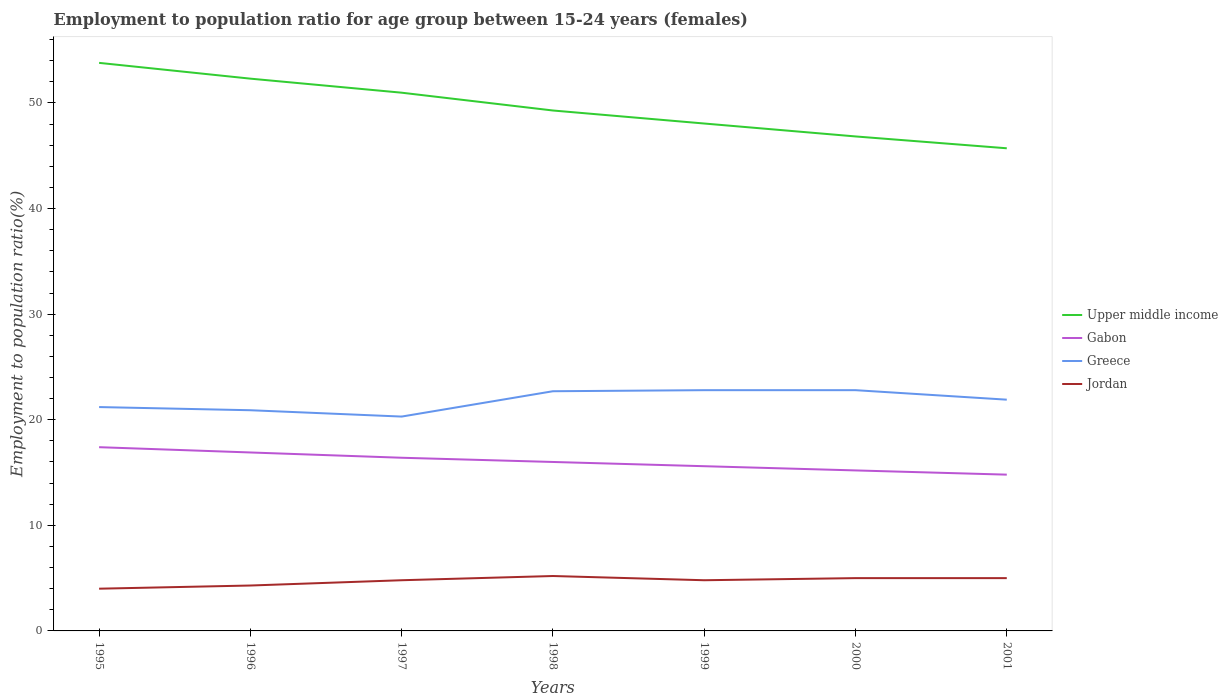How many different coloured lines are there?
Offer a very short reply. 4. Across all years, what is the maximum employment to population ratio in Gabon?
Provide a succinct answer. 14.8. In which year was the employment to population ratio in Jordan maximum?
Offer a terse response. 1995. What is the total employment to population ratio in Greece in the graph?
Offer a terse response. 0.9. What is the difference between the highest and the second highest employment to population ratio in Jordan?
Keep it short and to the point. 1.2. What is the difference between the highest and the lowest employment to population ratio in Jordan?
Keep it short and to the point. 5. How many lines are there?
Make the answer very short. 4. How many years are there in the graph?
Provide a succinct answer. 7. Does the graph contain any zero values?
Your response must be concise. No. Where does the legend appear in the graph?
Ensure brevity in your answer.  Center right. What is the title of the graph?
Provide a succinct answer. Employment to population ratio for age group between 15-24 years (females). What is the Employment to population ratio(%) of Upper middle income in 1995?
Keep it short and to the point. 53.8. What is the Employment to population ratio(%) in Gabon in 1995?
Your answer should be compact. 17.4. What is the Employment to population ratio(%) in Greece in 1995?
Your response must be concise. 21.2. What is the Employment to population ratio(%) of Upper middle income in 1996?
Offer a very short reply. 52.3. What is the Employment to population ratio(%) of Gabon in 1996?
Your answer should be very brief. 16.9. What is the Employment to population ratio(%) of Greece in 1996?
Your answer should be very brief. 20.9. What is the Employment to population ratio(%) in Jordan in 1996?
Your answer should be compact. 4.3. What is the Employment to population ratio(%) of Upper middle income in 1997?
Provide a short and direct response. 50.97. What is the Employment to population ratio(%) in Gabon in 1997?
Provide a short and direct response. 16.4. What is the Employment to population ratio(%) of Greece in 1997?
Provide a succinct answer. 20.3. What is the Employment to population ratio(%) in Jordan in 1997?
Keep it short and to the point. 4.8. What is the Employment to population ratio(%) in Upper middle income in 1998?
Provide a short and direct response. 49.29. What is the Employment to population ratio(%) of Gabon in 1998?
Your answer should be compact. 16. What is the Employment to population ratio(%) of Greece in 1998?
Provide a succinct answer. 22.7. What is the Employment to population ratio(%) of Jordan in 1998?
Offer a terse response. 5.2. What is the Employment to population ratio(%) of Upper middle income in 1999?
Give a very brief answer. 48.05. What is the Employment to population ratio(%) in Gabon in 1999?
Ensure brevity in your answer.  15.6. What is the Employment to population ratio(%) in Greece in 1999?
Give a very brief answer. 22.8. What is the Employment to population ratio(%) of Jordan in 1999?
Offer a terse response. 4.8. What is the Employment to population ratio(%) of Upper middle income in 2000?
Give a very brief answer. 46.83. What is the Employment to population ratio(%) of Gabon in 2000?
Make the answer very short. 15.2. What is the Employment to population ratio(%) in Greece in 2000?
Offer a terse response. 22.8. What is the Employment to population ratio(%) of Upper middle income in 2001?
Make the answer very short. 45.71. What is the Employment to population ratio(%) of Gabon in 2001?
Offer a very short reply. 14.8. What is the Employment to population ratio(%) of Greece in 2001?
Offer a very short reply. 21.9. What is the Employment to population ratio(%) of Jordan in 2001?
Give a very brief answer. 5. Across all years, what is the maximum Employment to population ratio(%) in Upper middle income?
Make the answer very short. 53.8. Across all years, what is the maximum Employment to population ratio(%) of Gabon?
Your response must be concise. 17.4. Across all years, what is the maximum Employment to population ratio(%) of Greece?
Keep it short and to the point. 22.8. Across all years, what is the maximum Employment to population ratio(%) in Jordan?
Your response must be concise. 5.2. Across all years, what is the minimum Employment to population ratio(%) in Upper middle income?
Ensure brevity in your answer.  45.71. Across all years, what is the minimum Employment to population ratio(%) of Gabon?
Offer a terse response. 14.8. Across all years, what is the minimum Employment to population ratio(%) of Greece?
Provide a short and direct response. 20.3. Across all years, what is the minimum Employment to population ratio(%) of Jordan?
Provide a short and direct response. 4. What is the total Employment to population ratio(%) of Upper middle income in the graph?
Offer a terse response. 346.95. What is the total Employment to population ratio(%) in Gabon in the graph?
Your answer should be very brief. 112.3. What is the total Employment to population ratio(%) in Greece in the graph?
Your answer should be compact. 152.6. What is the total Employment to population ratio(%) in Jordan in the graph?
Provide a succinct answer. 33.1. What is the difference between the Employment to population ratio(%) of Upper middle income in 1995 and that in 1996?
Your answer should be very brief. 1.49. What is the difference between the Employment to population ratio(%) in Jordan in 1995 and that in 1996?
Offer a very short reply. -0.3. What is the difference between the Employment to population ratio(%) in Upper middle income in 1995 and that in 1997?
Your answer should be very brief. 2.82. What is the difference between the Employment to population ratio(%) of Gabon in 1995 and that in 1997?
Your answer should be compact. 1. What is the difference between the Employment to population ratio(%) of Greece in 1995 and that in 1997?
Give a very brief answer. 0.9. What is the difference between the Employment to population ratio(%) of Jordan in 1995 and that in 1997?
Provide a succinct answer. -0.8. What is the difference between the Employment to population ratio(%) of Upper middle income in 1995 and that in 1998?
Your response must be concise. 4.51. What is the difference between the Employment to population ratio(%) of Greece in 1995 and that in 1998?
Offer a terse response. -1.5. What is the difference between the Employment to population ratio(%) in Jordan in 1995 and that in 1998?
Your answer should be compact. -1.2. What is the difference between the Employment to population ratio(%) of Upper middle income in 1995 and that in 1999?
Keep it short and to the point. 5.74. What is the difference between the Employment to population ratio(%) of Jordan in 1995 and that in 1999?
Your response must be concise. -0.8. What is the difference between the Employment to population ratio(%) in Upper middle income in 1995 and that in 2000?
Offer a terse response. 6.97. What is the difference between the Employment to population ratio(%) of Gabon in 1995 and that in 2000?
Your response must be concise. 2.2. What is the difference between the Employment to population ratio(%) of Greece in 1995 and that in 2000?
Offer a very short reply. -1.6. What is the difference between the Employment to population ratio(%) in Jordan in 1995 and that in 2000?
Ensure brevity in your answer.  -1. What is the difference between the Employment to population ratio(%) in Upper middle income in 1995 and that in 2001?
Your answer should be very brief. 8.09. What is the difference between the Employment to population ratio(%) in Gabon in 1995 and that in 2001?
Your response must be concise. 2.6. What is the difference between the Employment to population ratio(%) in Greece in 1995 and that in 2001?
Give a very brief answer. -0.7. What is the difference between the Employment to population ratio(%) in Upper middle income in 1996 and that in 1997?
Ensure brevity in your answer.  1.33. What is the difference between the Employment to population ratio(%) of Gabon in 1996 and that in 1997?
Offer a very short reply. 0.5. What is the difference between the Employment to population ratio(%) in Greece in 1996 and that in 1997?
Offer a very short reply. 0.6. What is the difference between the Employment to population ratio(%) of Upper middle income in 1996 and that in 1998?
Your answer should be compact. 3.02. What is the difference between the Employment to population ratio(%) in Upper middle income in 1996 and that in 1999?
Make the answer very short. 4.25. What is the difference between the Employment to population ratio(%) of Greece in 1996 and that in 1999?
Your answer should be compact. -1.9. What is the difference between the Employment to population ratio(%) in Upper middle income in 1996 and that in 2000?
Keep it short and to the point. 5.47. What is the difference between the Employment to population ratio(%) in Gabon in 1996 and that in 2000?
Give a very brief answer. 1.7. What is the difference between the Employment to population ratio(%) in Upper middle income in 1996 and that in 2001?
Keep it short and to the point. 6.59. What is the difference between the Employment to population ratio(%) of Gabon in 1996 and that in 2001?
Offer a very short reply. 2.1. What is the difference between the Employment to population ratio(%) in Jordan in 1996 and that in 2001?
Offer a terse response. -0.7. What is the difference between the Employment to population ratio(%) in Upper middle income in 1997 and that in 1998?
Make the answer very short. 1.69. What is the difference between the Employment to population ratio(%) of Greece in 1997 and that in 1998?
Your answer should be compact. -2.4. What is the difference between the Employment to population ratio(%) in Jordan in 1997 and that in 1998?
Keep it short and to the point. -0.4. What is the difference between the Employment to population ratio(%) in Upper middle income in 1997 and that in 1999?
Offer a very short reply. 2.92. What is the difference between the Employment to population ratio(%) in Jordan in 1997 and that in 1999?
Provide a succinct answer. 0. What is the difference between the Employment to population ratio(%) in Upper middle income in 1997 and that in 2000?
Your response must be concise. 4.14. What is the difference between the Employment to population ratio(%) in Gabon in 1997 and that in 2000?
Offer a terse response. 1.2. What is the difference between the Employment to population ratio(%) of Greece in 1997 and that in 2000?
Keep it short and to the point. -2.5. What is the difference between the Employment to population ratio(%) of Upper middle income in 1997 and that in 2001?
Your response must be concise. 5.26. What is the difference between the Employment to population ratio(%) in Gabon in 1997 and that in 2001?
Your response must be concise. 1.6. What is the difference between the Employment to population ratio(%) of Greece in 1997 and that in 2001?
Offer a very short reply. -1.6. What is the difference between the Employment to population ratio(%) in Upper middle income in 1998 and that in 1999?
Provide a succinct answer. 1.23. What is the difference between the Employment to population ratio(%) of Greece in 1998 and that in 1999?
Your answer should be compact. -0.1. What is the difference between the Employment to population ratio(%) of Upper middle income in 1998 and that in 2000?
Give a very brief answer. 2.46. What is the difference between the Employment to population ratio(%) in Greece in 1998 and that in 2000?
Provide a succinct answer. -0.1. What is the difference between the Employment to population ratio(%) in Upper middle income in 1998 and that in 2001?
Give a very brief answer. 3.58. What is the difference between the Employment to population ratio(%) in Upper middle income in 1999 and that in 2000?
Give a very brief answer. 1.22. What is the difference between the Employment to population ratio(%) of Gabon in 1999 and that in 2000?
Ensure brevity in your answer.  0.4. What is the difference between the Employment to population ratio(%) in Greece in 1999 and that in 2000?
Offer a very short reply. 0. What is the difference between the Employment to population ratio(%) of Jordan in 1999 and that in 2000?
Offer a very short reply. -0.2. What is the difference between the Employment to population ratio(%) of Upper middle income in 1999 and that in 2001?
Ensure brevity in your answer.  2.35. What is the difference between the Employment to population ratio(%) in Upper middle income in 2000 and that in 2001?
Make the answer very short. 1.12. What is the difference between the Employment to population ratio(%) of Greece in 2000 and that in 2001?
Give a very brief answer. 0.9. What is the difference between the Employment to population ratio(%) in Jordan in 2000 and that in 2001?
Provide a succinct answer. 0. What is the difference between the Employment to population ratio(%) of Upper middle income in 1995 and the Employment to population ratio(%) of Gabon in 1996?
Ensure brevity in your answer.  36.9. What is the difference between the Employment to population ratio(%) in Upper middle income in 1995 and the Employment to population ratio(%) in Greece in 1996?
Give a very brief answer. 32.9. What is the difference between the Employment to population ratio(%) of Upper middle income in 1995 and the Employment to population ratio(%) of Jordan in 1996?
Your answer should be very brief. 49.5. What is the difference between the Employment to population ratio(%) in Gabon in 1995 and the Employment to population ratio(%) in Jordan in 1996?
Offer a very short reply. 13.1. What is the difference between the Employment to population ratio(%) of Upper middle income in 1995 and the Employment to population ratio(%) of Gabon in 1997?
Ensure brevity in your answer.  37.4. What is the difference between the Employment to population ratio(%) in Upper middle income in 1995 and the Employment to population ratio(%) in Greece in 1997?
Give a very brief answer. 33.5. What is the difference between the Employment to population ratio(%) in Upper middle income in 1995 and the Employment to population ratio(%) in Jordan in 1997?
Provide a short and direct response. 49. What is the difference between the Employment to population ratio(%) in Gabon in 1995 and the Employment to population ratio(%) in Jordan in 1997?
Make the answer very short. 12.6. What is the difference between the Employment to population ratio(%) of Greece in 1995 and the Employment to population ratio(%) of Jordan in 1997?
Offer a very short reply. 16.4. What is the difference between the Employment to population ratio(%) in Upper middle income in 1995 and the Employment to population ratio(%) in Gabon in 1998?
Ensure brevity in your answer.  37.8. What is the difference between the Employment to population ratio(%) of Upper middle income in 1995 and the Employment to population ratio(%) of Greece in 1998?
Ensure brevity in your answer.  31.1. What is the difference between the Employment to population ratio(%) of Upper middle income in 1995 and the Employment to population ratio(%) of Jordan in 1998?
Provide a succinct answer. 48.6. What is the difference between the Employment to population ratio(%) in Gabon in 1995 and the Employment to population ratio(%) in Greece in 1998?
Offer a terse response. -5.3. What is the difference between the Employment to population ratio(%) of Greece in 1995 and the Employment to population ratio(%) of Jordan in 1998?
Your answer should be compact. 16. What is the difference between the Employment to population ratio(%) of Upper middle income in 1995 and the Employment to population ratio(%) of Gabon in 1999?
Ensure brevity in your answer.  38.2. What is the difference between the Employment to population ratio(%) of Upper middle income in 1995 and the Employment to population ratio(%) of Greece in 1999?
Give a very brief answer. 31. What is the difference between the Employment to population ratio(%) of Upper middle income in 1995 and the Employment to population ratio(%) of Jordan in 1999?
Keep it short and to the point. 49. What is the difference between the Employment to population ratio(%) in Gabon in 1995 and the Employment to population ratio(%) in Greece in 1999?
Offer a terse response. -5.4. What is the difference between the Employment to population ratio(%) in Greece in 1995 and the Employment to population ratio(%) in Jordan in 1999?
Offer a terse response. 16.4. What is the difference between the Employment to population ratio(%) of Upper middle income in 1995 and the Employment to population ratio(%) of Gabon in 2000?
Ensure brevity in your answer.  38.6. What is the difference between the Employment to population ratio(%) of Upper middle income in 1995 and the Employment to population ratio(%) of Greece in 2000?
Offer a terse response. 31. What is the difference between the Employment to population ratio(%) of Upper middle income in 1995 and the Employment to population ratio(%) of Jordan in 2000?
Make the answer very short. 48.8. What is the difference between the Employment to population ratio(%) in Gabon in 1995 and the Employment to population ratio(%) in Greece in 2000?
Offer a terse response. -5.4. What is the difference between the Employment to population ratio(%) of Gabon in 1995 and the Employment to population ratio(%) of Jordan in 2000?
Make the answer very short. 12.4. What is the difference between the Employment to population ratio(%) of Upper middle income in 1995 and the Employment to population ratio(%) of Gabon in 2001?
Give a very brief answer. 39. What is the difference between the Employment to population ratio(%) of Upper middle income in 1995 and the Employment to population ratio(%) of Greece in 2001?
Give a very brief answer. 31.9. What is the difference between the Employment to population ratio(%) in Upper middle income in 1995 and the Employment to population ratio(%) in Jordan in 2001?
Ensure brevity in your answer.  48.8. What is the difference between the Employment to population ratio(%) of Gabon in 1995 and the Employment to population ratio(%) of Greece in 2001?
Your answer should be very brief. -4.5. What is the difference between the Employment to population ratio(%) of Gabon in 1995 and the Employment to population ratio(%) of Jordan in 2001?
Ensure brevity in your answer.  12.4. What is the difference between the Employment to population ratio(%) in Greece in 1995 and the Employment to population ratio(%) in Jordan in 2001?
Give a very brief answer. 16.2. What is the difference between the Employment to population ratio(%) of Upper middle income in 1996 and the Employment to population ratio(%) of Gabon in 1997?
Offer a very short reply. 35.9. What is the difference between the Employment to population ratio(%) of Upper middle income in 1996 and the Employment to population ratio(%) of Greece in 1997?
Your answer should be very brief. 32. What is the difference between the Employment to population ratio(%) in Upper middle income in 1996 and the Employment to population ratio(%) in Jordan in 1997?
Offer a terse response. 47.5. What is the difference between the Employment to population ratio(%) of Gabon in 1996 and the Employment to population ratio(%) of Greece in 1997?
Make the answer very short. -3.4. What is the difference between the Employment to population ratio(%) of Gabon in 1996 and the Employment to population ratio(%) of Jordan in 1997?
Make the answer very short. 12.1. What is the difference between the Employment to population ratio(%) in Upper middle income in 1996 and the Employment to population ratio(%) in Gabon in 1998?
Provide a short and direct response. 36.3. What is the difference between the Employment to population ratio(%) of Upper middle income in 1996 and the Employment to population ratio(%) of Greece in 1998?
Make the answer very short. 29.6. What is the difference between the Employment to population ratio(%) in Upper middle income in 1996 and the Employment to population ratio(%) in Jordan in 1998?
Make the answer very short. 47.1. What is the difference between the Employment to population ratio(%) in Gabon in 1996 and the Employment to population ratio(%) in Greece in 1998?
Provide a succinct answer. -5.8. What is the difference between the Employment to population ratio(%) of Greece in 1996 and the Employment to population ratio(%) of Jordan in 1998?
Your answer should be compact. 15.7. What is the difference between the Employment to population ratio(%) of Upper middle income in 1996 and the Employment to population ratio(%) of Gabon in 1999?
Offer a very short reply. 36.7. What is the difference between the Employment to population ratio(%) in Upper middle income in 1996 and the Employment to population ratio(%) in Greece in 1999?
Offer a very short reply. 29.5. What is the difference between the Employment to population ratio(%) in Upper middle income in 1996 and the Employment to population ratio(%) in Jordan in 1999?
Your response must be concise. 47.5. What is the difference between the Employment to population ratio(%) of Gabon in 1996 and the Employment to population ratio(%) of Greece in 1999?
Provide a succinct answer. -5.9. What is the difference between the Employment to population ratio(%) in Gabon in 1996 and the Employment to population ratio(%) in Jordan in 1999?
Your answer should be compact. 12.1. What is the difference between the Employment to population ratio(%) in Greece in 1996 and the Employment to population ratio(%) in Jordan in 1999?
Offer a terse response. 16.1. What is the difference between the Employment to population ratio(%) of Upper middle income in 1996 and the Employment to population ratio(%) of Gabon in 2000?
Provide a succinct answer. 37.1. What is the difference between the Employment to population ratio(%) of Upper middle income in 1996 and the Employment to population ratio(%) of Greece in 2000?
Provide a short and direct response. 29.5. What is the difference between the Employment to population ratio(%) of Upper middle income in 1996 and the Employment to population ratio(%) of Jordan in 2000?
Ensure brevity in your answer.  47.3. What is the difference between the Employment to population ratio(%) in Gabon in 1996 and the Employment to population ratio(%) in Greece in 2000?
Offer a very short reply. -5.9. What is the difference between the Employment to population ratio(%) in Gabon in 1996 and the Employment to population ratio(%) in Jordan in 2000?
Offer a terse response. 11.9. What is the difference between the Employment to population ratio(%) of Upper middle income in 1996 and the Employment to population ratio(%) of Gabon in 2001?
Make the answer very short. 37.5. What is the difference between the Employment to population ratio(%) in Upper middle income in 1996 and the Employment to population ratio(%) in Greece in 2001?
Provide a succinct answer. 30.4. What is the difference between the Employment to population ratio(%) in Upper middle income in 1996 and the Employment to population ratio(%) in Jordan in 2001?
Your answer should be compact. 47.3. What is the difference between the Employment to population ratio(%) in Gabon in 1996 and the Employment to population ratio(%) in Greece in 2001?
Your answer should be compact. -5. What is the difference between the Employment to population ratio(%) in Gabon in 1996 and the Employment to population ratio(%) in Jordan in 2001?
Offer a very short reply. 11.9. What is the difference between the Employment to population ratio(%) in Upper middle income in 1997 and the Employment to population ratio(%) in Gabon in 1998?
Provide a succinct answer. 34.97. What is the difference between the Employment to population ratio(%) in Upper middle income in 1997 and the Employment to population ratio(%) in Greece in 1998?
Keep it short and to the point. 28.27. What is the difference between the Employment to population ratio(%) in Upper middle income in 1997 and the Employment to population ratio(%) in Jordan in 1998?
Offer a very short reply. 45.77. What is the difference between the Employment to population ratio(%) in Upper middle income in 1997 and the Employment to population ratio(%) in Gabon in 1999?
Provide a short and direct response. 35.37. What is the difference between the Employment to population ratio(%) in Upper middle income in 1997 and the Employment to population ratio(%) in Greece in 1999?
Your answer should be very brief. 28.17. What is the difference between the Employment to population ratio(%) of Upper middle income in 1997 and the Employment to population ratio(%) of Jordan in 1999?
Your answer should be very brief. 46.17. What is the difference between the Employment to population ratio(%) of Greece in 1997 and the Employment to population ratio(%) of Jordan in 1999?
Your answer should be very brief. 15.5. What is the difference between the Employment to population ratio(%) of Upper middle income in 1997 and the Employment to population ratio(%) of Gabon in 2000?
Ensure brevity in your answer.  35.77. What is the difference between the Employment to population ratio(%) of Upper middle income in 1997 and the Employment to population ratio(%) of Greece in 2000?
Your response must be concise. 28.17. What is the difference between the Employment to population ratio(%) of Upper middle income in 1997 and the Employment to population ratio(%) of Jordan in 2000?
Keep it short and to the point. 45.97. What is the difference between the Employment to population ratio(%) in Upper middle income in 1997 and the Employment to population ratio(%) in Gabon in 2001?
Your answer should be very brief. 36.17. What is the difference between the Employment to population ratio(%) in Upper middle income in 1997 and the Employment to population ratio(%) in Greece in 2001?
Ensure brevity in your answer.  29.07. What is the difference between the Employment to population ratio(%) of Upper middle income in 1997 and the Employment to population ratio(%) of Jordan in 2001?
Provide a short and direct response. 45.97. What is the difference between the Employment to population ratio(%) in Gabon in 1997 and the Employment to population ratio(%) in Greece in 2001?
Make the answer very short. -5.5. What is the difference between the Employment to population ratio(%) of Greece in 1997 and the Employment to population ratio(%) of Jordan in 2001?
Your response must be concise. 15.3. What is the difference between the Employment to population ratio(%) in Upper middle income in 1998 and the Employment to population ratio(%) in Gabon in 1999?
Make the answer very short. 33.69. What is the difference between the Employment to population ratio(%) of Upper middle income in 1998 and the Employment to population ratio(%) of Greece in 1999?
Provide a succinct answer. 26.49. What is the difference between the Employment to population ratio(%) in Upper middle income in 1998 and the Employment to population ratio(%) in Jordan in 1999?
Offer a very short reply. 44.49. What is the difference between the Employment to population ratio(%) of Gabon in 1998 and the Employment to population ratio(%) of Greece in 1999?
Keep it short and to the point. -6.8. What is the difference between the Employment to population ratio(%) in Upper middle income in 1998 and the Employment to population ratio(%) in Gabon in 2000?
Your answer should be very brief. 34.09. What is the difference between the Employment to population ratio(%) in Upper middle income in 1998 and the Employment to population ratio(%) in Greece in 2000?
Give a very brief answer. 26.49. What is the difference between the Employment to population ratio(%) of Upper middle income in 1998 and the Employment to population ratio(%) of Jordan in 2000?
Offer a terse response. 44.29. What is the difference between the Employment to population ratio(%) of Gabon in 1998 and the Employment to population ratio(%) of Greece in 2000?
Your response must be concise. -6.8. What is the difference between the Employment to population ratio(%) in Gabon in 1998 and the Employment to population ratio(%) in Jordan in 2000?
Provide a short and direct response. 11. What is the difference between the Employment to population ratio(%) in Greece in 1998 and the Employment to population ratio(%) in Jordan in 2000?
Make the answer very short. 17.7. What is the difference between the Employment to population ratio(%) in Upper middle income in 1998 and the Employment to population ratio(%) in Gabon in 2001?
Keep it short and to the point. 34.49. What is the difference between the Employment to population ratio(%) of Upper middle income in 1998 and the Employment to population ratio(%) of Greece in 2001?
Offer a very short reply. 27.39. What is the difference between the Employment to population ratio(%) in Upper middle income in 1998 and the Employment to population ratio(%) in Jordan in 2001?
Ensure brevity in your answer.  44.29. What is the difference between the Employment to population ratio(%) in Gabon in 1998 and the Employment to population ratio(%) in Jordan in 2001?
Provide a succinct answer. 11. What is the difference between the Employment to population ratio(%) in Upper middle income in 1999 and the Employment to population ratio(%) in Gabon in 2000?
Give a very brief answer. 32.85. What is the difference between the Employment to population ratio(%) of Upper middle income in 1999 and the Employment to population ratio(%) of Greece in 2000?
Your answer should be compact. 25.25. What is the difference between the Employment to population ratio(%) in Upper middle income in 1999 and the Employment to population ratio(%) in Jordan in 2000?
Your answer should be very brief. 43.05. What is the difference between the Employment to population ratio(%) in Gabon in 1999 and the Employment to population ratio(%) in Greece in 2000?
Provide a short and direct response. -7.2. What is the difference between the Employment to population ratio(%) of Gabon in 1999 and the Employment to population ratio(%) of Jordan in 2000?
Offer a terse response. 10.6. What is the difference between the Employment to population ratio(%) of Upper middle income in 1999 and the Employment to population ratio(%) of Gabon in 2001?
Your answer should be very brief. 33.25. What is the difference between the Employment to population ratio(%) of Upper middle income in 1999 and the Employment to population ratio(%) of Greece in 2001?
Offer a very short reply. 26.15. What is the difference between the Employment to population ratio(%) in Upper middle income in 1999 and the Employment to population ratio(%) in Jordan in 2001?
Provide a succinct answer. 43.05. What is the difference between the Employment to population ratio(%) of Upper middle income in 2000 and the Employment to population ratio(%) of Gabon in 2001?
Ensure brevity in your answer.  32.03. What is the difference between the Employment to population ratio(%) of Upper middle income in 2000 and the Employment to population ratio(%) of Greece in 2001?
Offer a very short reply. 24.93. What is the difference between the Employment to population ratio(%) of Upper middle income in 2000 and the Employment to population ratio(%) of Jordan in 2001?
Provide a succinct answer. 41.83. What is the difference between the Employment to population ratio(%) in Greece in 2000 and the Employment to population ratio(%) in Jordan in 2001?
Offer a very short reply. 17.8. What is the average Employment to population ratio(%) of Upper middle income per year?
Your answer should be compact. 49.56. What is the average Employment to population ratio(%) of Gabon per year?
Offer a terse response. 16.04. What is the average Employment to population ratio(%) in Greece per year?
Your answer should be compact. 21.8. What is the average Employment to population ratio(%) of Jordan per year?
Your answer should be compact. 4.73. In the year 1995, what is the difference between the Employment to population ratio(%) in Upper middle income and Employment to population ratio(%) in Gabon?
Give a very brief answer. 36.4. In the year 1995, what is the difference between the Employment to population ratio(%) of Upper middle income and Employment to population ratio(%) of Greece?
Make the answer very short. 32.6. In the year 1995, what is the difference between the Employment to population ratio(%) in Upper middle income and Employment to population ratio(%) in Jordan?
Your answer should be compact. 49.8. In the year 1995, what is the difference between the Employment to population ratio(%) in Gabon and Employment to population ratio(%) in Jordan?
Your response must be concise. 13.4. In the year 1995, what is the difference between the Employment to population ratio(%) in Greece and Employment to population ratio(%) in Jordan?
Give a very brief answer. 17.2. In the year 1996, what is the difference between the Employment to population ratio(%) in Upper middle income and Employment to population ratio(%) in Gabon?
Your answer should be very brief. 35.4. In the year 1996, what is the difference between the Employment to population ratio(%) of Upper middle income and Employment to population ratio(%) of Greece?
Give a very brief answer. 31.4. In the year 1996, what is the difference between the Employment to population ratio(%) of Upper middle income and Employment to population ratio(%) of Jordan?
Your answer should be compact. 48. In the year 1996, what is the difference between the Employment to population ratio(%) of Gabon and Employment to population ratio(%) of Jordan?
Offer a terse response. 12.6. In the year 1996, what is the difference between the Employment to population ratio(%) in Greece and Employment to population ratio(%) in Jordan?
Give a very brief answer. 16.6. In the year 1997, what is the difference between the Employment to population ratio(%) in Upper middle income and Employment to population ratio(%) in Gabon?
Your response must be concise. 34.57. In the year 1997, what is the difference between the Employment to population ratio(%) in Upper middle income and Employment to population ratio(%) in Greece?
Make the answer very short. 30.67. In the year 1997, what is the difference between the Employment to population ratio(%) in Upper middle income and Employment to population ratio(%) in Jordan?
Your response must be concise. 46.17. In the year 1997, what is the difference between the Employment to population ratio(%) in Gabon and Employment to population ratio(%) in Greece?
Offer a terse response. -3.9. In the year 1997, what is the difference between the Employment to population ratio(%) in Gabon and Employment to population ratio(%) in Jordan?
Provide a short and direct response. 11.6. In the year 1998, what is the difference between the Employment to population ratio(%) of Upper middle income and Employment to population ratio(%) of Gabon?
Keep it short and to the point. 33.29. In the year 1998, what is the difference between the Employment to population ratio(%) in Upper middle income and Employment to population ratio(%) in Greece?
Provide a short and direct response. 26.59. In the year 1998, what is the difference between the Employment to population ratio(%) of Upper middle income and Employment to population ratio(%) of Jordan?
Offer a terse response. 44.09. In the year 1998, what is the difference between the Employment to population ratio(%) of Gabon and Employment to population ratio(%) of Greece?
Offer a very short reply. -6.7. In the year 1999, what is the difference between the Employment to population ratio(%) in Upper middle income and Employment to population ratio(%) in Gabon?
Your answer should be very brief. 32.45. In the year 1999, what is the difference between the Employment to population ratio(%) in Upper middle income and Employment to population ratio(%) in Greece?
Your answer should be compact. 25.25. In the year 1999, what is the difference between the Employment to population ratio(%) of Upper middle income and Employment to population ratio(%) of Jordan?
Ensure brevity in your answer.  43.25. In the year 1999, what is the difference between the Employment to population ratio(%) in Gabon and Employment to population ratio(%) in Jordan?
Offer a terse response. 10.8. In the year 1999, what is the difference between the Employment to population ratio(%) in Greece and Employment to population ratio(%) in Jordan?
Give a very brief answer. 18. In the year 2000, what is the difference between the Employment to population ratio(%) of Upper middle income and Employment to population ratio(%) of Gabon?
Offer a very short reply. 31.63. In the year 2000, what is the difference between the Employment to population ratio(%) of Upper middle income and Employment to population ratio(%) of Greece?
Provide a succinct answer. 24.03. In the year 2000, what is the difference between the Employment to population ratio(%) of Upper middle income and Employment to population ratio(%) of Jordan?
Offer a very short reply. 41.83. In the year 2000, what is the difference between the Employment to population ratio(%) in Gabon and Employment to population ratio(%) in Greece?
Ensure brevity in your answer.  -7.6. In the year 2001, what is the difference between the Employment to population ratio(%) in Upper middle income and Employment to population ratio(%) in Gabon?
Ensure brevity in your answer.  30.91. In the year 2001, what is the difference between the Employment to population ratio(%) in Upper middle income and Employment to population ratio(%) in Greece?
Offer a very short reply. 23.81. In the year 2001, what is the difference between the Employment to population ratio(%) in Upper middle income and Employment to population ratio(%) in Jordan?
Provide a short and direct response. 40.71. In the year 2001, what is the difference between the Employment to population ratio(%) in Gabon and Employment to population ratio(%) in Greece?
Offer a very short reply. -7.1. In the year 2001, what is the difference between the Employment to population ratio(%) in Gabon and Employment to population ratio(%) in Jordan?
Your answer should be compact. 9.8. In the year 2001, what is the difference between the Employment to population ratio(%) in Greece and Employment to population ratio(%) in Jordan?
Your answer should be compact. 16.9. What is the ratio of the Employment to population ratio(%) of Upper middle income in 1995 to that in 1996?
Ensure brevity in your answer.  1.03. What is the ratio of the Employment to population ratio(%) in Gabon in 1995 to that in 1996?
Offer a very short reply. 1.03. What is the ratio of the Employment to population ratio(%) in Greece in 1995 to that in 1996?
Your answer should be compact. 1.01. What is the ratio of the Employment to population ratio(%) in Jordan in 1995 to that in 1996?
Give a very brief answer. 0.93. What is the ratio of the Employment to population ratio(%) in Upper middle income in 1995 to that in 1997?
Your response must be concise. 1.06. What is the ratio of the Employment to population ratio(%) in Gabon in 1995 to that in 1997?
Keep it short and to the point. 1.06. What is the ratio of the Employment to population ratio(%) in Greece in 1995 to that in 1997?
Give a very brief answer. 1.04. What is the ratio of the Employment to population ratio(%) in Jordan in 1995 to that in 1997?
Provide a succinct answer. 0.83. What is the ratio of the Employment to population ratio(%) of Upper middle income in 1995 to that in 1998?
Provide a short and direct response. 1.09. What is the ratio of the Employment to population ratio(%) in Gabon in 1995 to that in 1998?
Offer a very short reply. 1.09. What is the ratio of the Employment to population ratio(%) of Greece in 1995 to that in 1998?
Provide a succinct answer. 0.93. What is the ratio of the Employment to population ratio(%) in Jordan in 1995 to that in 1998?
Make the answer very short. 0.77. What is the ratio of the Employment to population ratio(%) of Upper middle income in 1995 to that in 1999?
Your answer should be compact. 1.12. What is the ratio of the Employment to population ratio(%) in Gabon in 1995 to that in 1999?
Provide a short and direct response. 1.12. What is the ratio of the Employment to population ratio(%) of Greece in 1995 to that in 1999?
Make the answer very short. 0.93. What is the ratio of the Employment to population ratio(%) of Jordan in 1995 to that in 1999?
Your answer should be compact. 0.83. What is the ratio of the Employment to population ratio(%) in Upper middle income in 1995 to that in 2000?
Offer a very short reply. 1.15. What is the ratio of the Employment to population ratio(%) in Gabon in 1995 to that in 2000?
Make the answer very short. 1.14. What is the ratio of the Employment to population ratio(%) of Greece in 1995 to that in 2000?
Your answer should be compact. 0.93. What is the ratio of the Employment to population ratio(%) of Jordan in 1995 to that in 2000?
Offer a terse response. 0.8. What is the ratio of the Employment to population ratio(%) in Upper middle income in 1995 to that in 2001?
Your response must be concise. 1.18. What is the ratio of the Employment to population ratio(%) in Gabon in 1995 to that in 2001?
Offer a very short reply. 1.18. What is the ratio of the Employment to population ratio(%) of Greece in 1995 to that in 2001?
Give a very brief answer. 0.97. What is the ratio of the Employment to population ratio(%) in Upper middle income in 1996 to that in 1997?
Ensure brevity in your answer.  1.03. What is the ratio of the Employment to population ratio(%) of Gabon in 1996 to that in 1997?
Keep it short and to the point. 1.03. What is the ratio of the Employment to population ratio(%) of Greece in 1996 to that in 1997?
Give a very brief answer. 1.03. What is the ratio of the Employment to population ratio(%) of Jordan in 1996 to that in 1997?
Your answer should be very brief. 0.9. What is the ratio of the Employment to population ratio(%) of Upper middle income in 1996 to that in 1998?
Make the answer very short. 1.06. What is the ratio of the Employment to population ratio(%) in Gabon in 1996 to that in 1998?
Offer a very short reply. 1.06. What is the ratio of the Employment to population ratio(%) of Greece in 1996 to that in 1998?
Provide a succinct answer. 0.92. What is the ratio of the Employment to population ratio(%) of Jordan in 1996 to that in 1998?
Your answer should be compact. 0.83. What is the ratio of the Employment to population ratio(%) of Upper middle income in 1996 to that in 1999?
Keep it short and to the point. 1.09. What is the ratio of the Employment to population ratio(%) of Gabon in 1996 to that in 1999?
Keep it short and to the point. 1.08. What is the ratio of the Employment to population ratio(%) of Jordan in 1996 to that in 1999?
Give a very brief answer. 0.9. What is the ratio of the Employment to population ratio(%) in Upper middle income in 1996 to that in 2000?
Provide a short and direct response. 1.12. What is the ratio of the Employment to population ratio(%) in Gabon in 1996 to that in 2000?
Your answer should be very brief. 1.11. What is the ratio of the Employment to population ratio(%) of Jordan in 1996 to that in 2000?
Make the answer very short. 0.86. What is the ratio of the Employment to population ratio(%) in Upper middle income in 1996 to that in 2001?
Keep it short and to the point. 1.14. What is the ratio of the Employment to population ratio(%) in Gabon in 1996 to that in 2001?
Your answer should be compact. 1.14. What is the ratio of the Employment to population ratio(%) of Greece in 1996 to that in 2001?
Provide a short and direct response. 0.95. What is the ratio of the Employment to population ratio(%) of Jordan in 1996 to that in 2001?
Offer a very short reply. 0.86. What is the ratio of the Employment to population ratio(%) in Upper middle income in 1997 to that in 1998?
Provide a succinct answer. 1.03. What is the ratio of the Employment to population ratio(%) of Gabon in 1997 to that in 1998?
Make the answer very short. 1.02. What is the ratio of the Employment to population ratio(%) of Greece in 1997 to that in 1998?
Keep it short and to the point. 0.89. What is the ratio of the Employment to population ratio(%) of Upper middle income in 1997 to that in 1999?
Give a very brief answer. 1.06. What is the ratio of the Employment to population ratio(%) in Gabon in 1997 to that in 1999?
Make the answer very short. 1.05. What is the ratio of the Employment to population ratio(%) in Greece in 1997 to that in 1999?
Your response must be concise. 0.89. What is the ratio of the Employment to population ratio(%) in Jordan in 1997 to that in 1999?
Provide a short and direct response. 1. What is the ratio of the Employment to population ratio(%) of Upper middle income in 1997 to that in 2000?
Provide a succinct answer. 1.09. What is the ratio of the Employment to population ratio(%) of Gabon in 1997 to that in 2000?
Your answer should be very brief. 1.08. What is the ratio of the Employment to population ratio(%) of Greece in 1997 to that in 2000?
Offer a terse response. 0.89. What is the ratio of the Employment to population ratio(%) in Jordan in 1997 to that in 2000?
Give a very brief answer. 0.96. What is the ratio of the Employment to population ratio(%) of Upper middle income in 1997 to that in 2001?
Keep it short and to the point. 1.12. What is the ratio of the Employment to population ratio(%) in Gabon in 1997 to that in 2001?
Offer a terse response. 1.11. What is the ratio of the Employment to population ratio(%) of Greece in 1997 to that in 2001?
Make the answer very short. 0.93. What is the ratio of the Employment to population ratio(%) of Jordan in 1997 to that in 2001?
Ensure brevity in your answer.  0.96. What is the ratio of the Employment to population ratio(%) in Upper middle income in 1998 to that in 1999?
Offer a terse response. 1.03. What is the ratio of the Employment to population ratio(%) of Gabon in 1998 to that in 1999?
Your answer should be very brief. 1.03. What is the ratio of the Employment to population ratio(%) of Greece in 1998 to that in 1999?
Provide a short and direct response. 1. What is the ratio of the Employment to population ratio(%) in Jordan in 1998 to that in 1999?
Your answer should be very brief. 1.08. What is the ratio of the Employment to population ratio(%) in Upper middle income in 1998 to that in 2000?
Provide a succinct answer. 1.05. What is the ratio of the Employment to population ratio(%) in Gabon in 1998 to that in 2000?
Offer a terse response. 1.05. What is the ratio of the Employment to population ratio(%) in Greece in 1998 to that in 2000?
Ensure brevity in your answer.  1. What is the ratio of the Employment to population ratio(%) of Jordan in 1998 to that in 2000?
Your answer should be very brief. 1.04. What is the ratio of the Employment to population ratio(%) in Upper middle income in 1998 to that in 2001?
Offer a terse response. 1.08. What is the ratio of the Employment to population ratio(%) in Gabon in 1998 to that in 2001?
Your answer should be very brief. 1.08. What is the ratio of the Employment to population ratio(%) in Greece in 1998 to that in 2001?
Keep it short and to the point. 1.04. What is the ratio of the Employment to population ratio(%) in Upper middle income in 1999 to that in 2000?
Ensure brevity in your answer.  1.03. What is the ratio of the Employment to population ratio(%) of Gabon in 1999 to that in 2000?
Offer a terse response. 1.03. What is the ratio of the Employment to population ratio(%) of Greece in 1999 to that in 2000?
Your answer should be very brief. 1. What is the ratio of the Employment to population ratio(%) in Jordan in 1999 to that in 2000?
Offer a terse response. 0.96. What is the ratio of the Employment to population ratio(%) of Upper middle income in 1999 to that in 2001?
Offer a very short reply. 1.05. What is the ratio of the Employment to population ratio(%) in Gabon in 1999 to that in 2001?
Keep it short and to the point. 1.05. What is the ratio of the Employment to population ratio(%) of Greece in 1999 to that in 2001?
Keep it short and to the point. 1.04. What is the ratio of the Employment to population ratio(%) in Jordan in 1999 to that in 2001?
Ensure brevity in your answer.  0.96. What is the ratio of the Employment to population ratio(%) in Upper middle income in 2000 to that in 2001?
Make the answer very short. 1.02. What is the ratio of the Employment to population ratio(%) in Gabon in 2000 to that in 2001?
Offer a very short reply. 1.03. What is the ratio of the Employment to population ratio(%) of Greece in 2000 to that in 2001?
Provide a succinct answer. 1.04. What is the ratio of the Employment to population ratio(%) of Jordan in 2000 to that in 2001?
Provide a succinct answer. 1. What is the difference between the highest and the second highest Employment to population ratio(%) in Upper middle income?
Provide a short and direct response. 1.49. What is the difference between the highest and the second highest Employment to population ratio(%) of Greece?
Your response must be concise. 0. What is the difference between the highest and the second highest Employment to population ratio(%) in Jordan?
Ensure brevity in your answer.  0.2. What is the difference between the highest and the lowest Employment to population ratio(%) in Upper middle income?
Make the answer very short. 8.09. 